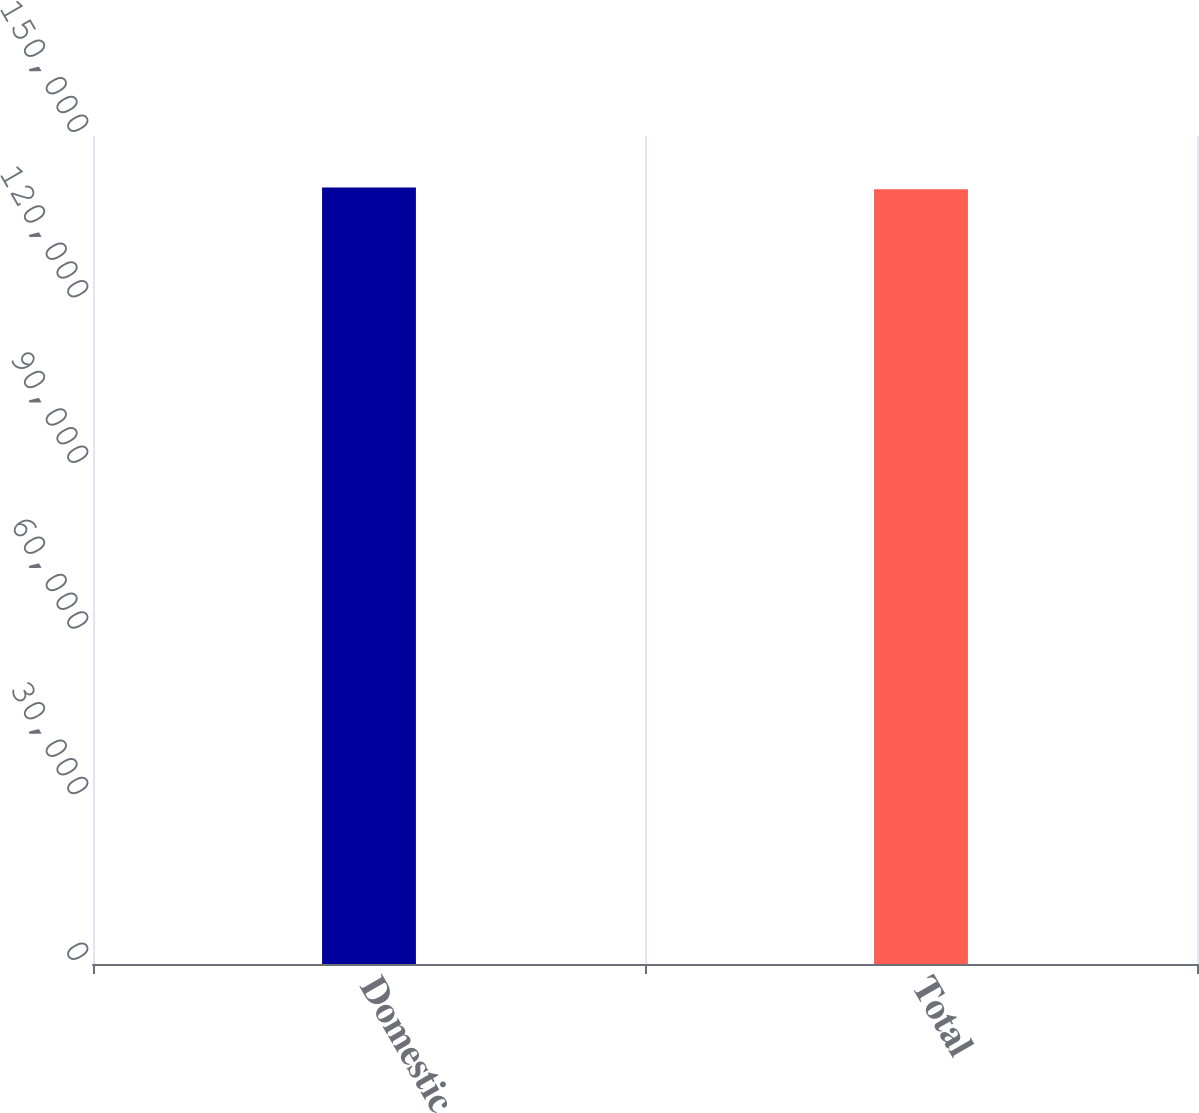Convert chart to OTSL. <chart><loc_0><loc_0><loc_500><loc_500><bar_chart><fcel>Domestic<fcel>Total<nl><fcel>140675<fcel>140351<nl></chart> 